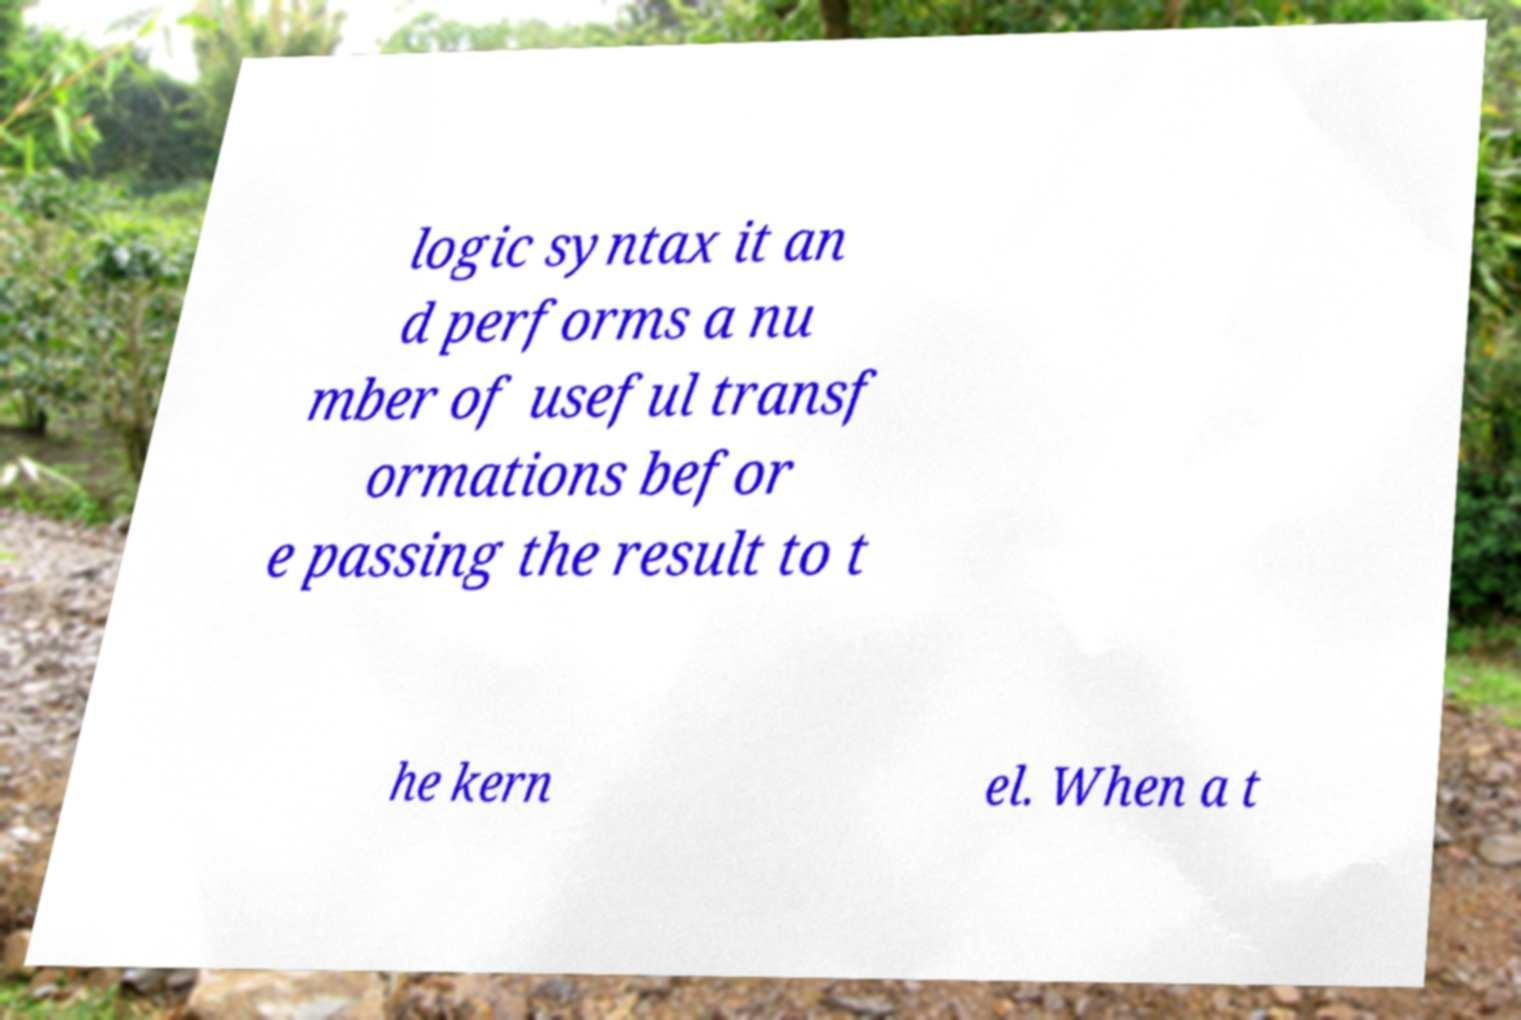Can you accurately transcribe the text from the provided image for me? logic syntax it an d performs a nu mber of useful transf ormations befor e passing the result to t he kern el. When a t 